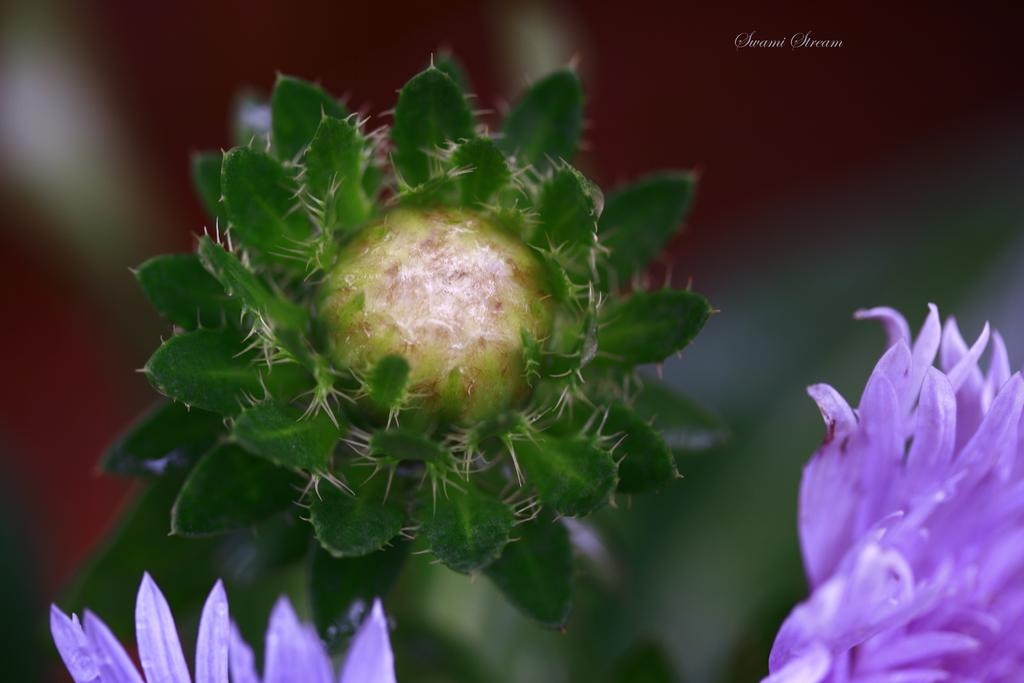What type of plants are visible in the image? There are flowers in the image. Where are the flowers located in relation to the image? The flowers are in the front of the image. What can be observed about the background of the image? The background of the image is blurry. Can you touch the pipe that is visible in the image? There is no pipe present in the image. 